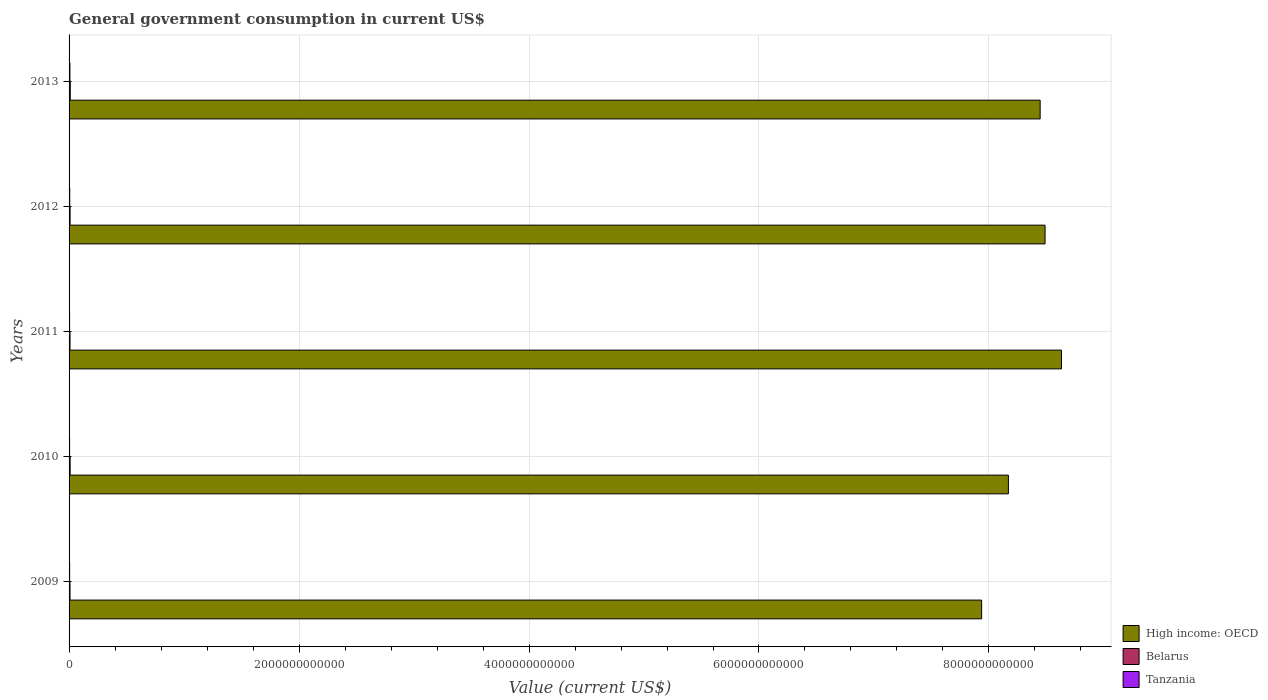How many different coloured bars are there?
Provide a short and direct response. 3. How many groups of bars are there?
Provide a succinct answer. 5. Are the number of bars on each tick of the Y-axis equal?
Your answer should be very brief. Yes. How many bars are there on the 2nd tick from the top?
Provide a succinct answer. 3. What is the label of the 3rd group of bars from the top?
Offer a very short reply. 2011. What is the government conusmption in Tanzania in 2012?
Provide a short and direct response. 5.76e+09. Across all years, what is the maximum government conusmption in Tanzania?
Make the answer very short. 7.24e+09. Across all years, what is the minimum government conusmption in High income: OECD?
Keep it short and to the point. 7.94e+12. In which year was the government conusmption in Belarus maximum?
Ensure brevity in your answer.  2013. In which year was the government conusmption in Belarus minimum?
Provide a short and direct response. 2009. What is the total government conusmption in High income: OECD in the graph?
Ensure brevity in your answer.  4.17e+13. What is the difference between the government conusmption in High income: OECD in 2010 and that in 2012?
Give a very brief answer. -3.19e+11. What is the difference between the government conusmption in High income: OECD in 2010 and the government conusmption in Belarus in 2011?
Your response must be concise. 8.16e+12. What is the average government conusmption in High income: OECD per year?
Ensure brevity in your answer.  8.33e+12. In the year 2009, what is the difference between the government conusmption in High income: OECD and government conusmption in Belarus?
Offer a terse response. 7.93e+12. What is the ratio of the government conusmption in Belarus in 2012 to that in 2013?
Give a very brief answer. 0.88. What is the difference between the highest and the second highest government conusmption in High income: OECD?
Provide a succinct answer. 1.42e+11. What is the difference between the highest and the lowest government conusmption in Tanzania?
Provide a succinct answer. 2.62e+09. In how many years, is the government conusmption in Belarus greater than the average government conusmption in Belarus taken over all years?
Give a very brief answer. 2. What does the 1st bar from the top in 2012 represents?
Your response must be concise. Tanzania. What does the 3rd bar from the bottom in 2009 represents?
Keep it short and to the point. Tanzania. How many bars are there?
Provide a short and direct response. 15. Are all the bars in the graph horizontal?
Offer a very short reply. Yes. How many years are there in the graph?
Give a very brief answer. 5. What is the difference between two consecutive major ticks on the X-axis?
Make the answer very short. 2.00e+12. Does the graph contain any zero values?
Give a very brief answer. No. Does the graph contain grids?
Your answer should be compact. Yes. Where does the legend appear in the graph?
Provide a short and direct response. Bottom right. How many legend labels are there?
Your answer should be very brief. 3. What is the title of the graph?
Make the answer very short. General government consumption in current US$. What is the label or title of the X-axis?
Your response must be concise. Value (current US$). What is the label or title of the Y-axis?
Keep it short and to the point. Years. What is the Value (current US$) in High income: OECD in 2009?
Ensure brevity in your answer.  7.94e+12. What is the Value (current US$) in Belarus in 2009?
Provide a succinct answer. 8.24e+09. What is the Value (current US$) of Tanzania in 2009?
Your answer should be very brief. 5.00e+09. What is the Value (current US$) in High income: OECD in 2010?
Provide a succinct answer. 8.17e+12. What is the Value (current US$) of Belarus in 2010?
Ensure brevity in your answer.  9.28e+09. What is the Value (current US$) of Tanzania in 2010?
Provide a succinct answer. 4.62e+09. What is the Value (current US$) of High income: OECD in 2011?
Provide a short and direct response. 8.63e+12. What is the Value (current US$) of Belarus in 2011?
Offer a very short reply. 8.32e+09. What is the Value (current US$) of Tanzania in 2011?
Your answer should be compact. 4.68e+09. What is the Value (current US$) in High income: OECD in 2012?
Ensure brevity in your answer.  8.49e+12. What is the Value (current US$) in Belarus in 2012?
Make the answer very short. 8.96e+09. What is the Value (current US$) in Tanzania in 2012?
Offer a terse response. 5.76e+09. What is the Value (current US$) of High income: OECD in 2013?
Ensure brevity in your answer.  8.45e+12. What is the Value (current US$) in Belarus in 2013?
Offer a very short reply. 1.02e+1. What is the Value (current US$) in Tanzania in 2013?
Your response must be concise. 7.24e+09. Across all years, what is the maximum Value (current US$) of High income: OECD?
Make the answer very short. 8.63e+12. Across all years, what is the maximum Value (current US$) in Belarus?
Make the answer very short. 1.02e+1. Across all years, what is the maximum Value (current US$) in Tanzania?
Provide a succinct answer. 7.24e+09. Across all years, what is the minimum Value (current US$) in High income: OECD?
Your answer should be very brief. 7.94e+12. Across all years, what is the minimum Value (current US$) in Belarus?
Provide a short and direct response. 8.24e+09. Across all years, what is the minimum Value (current US$) in Tanzania?
Offer a very short reply. 4.62e+09. What is the total Value (current US$) in High income: OECD in the graph?
Your answer should be very brief. 4.17e+13. What is the total Value (current US$) in Belarus in the graph?
Provide a short and direct response. 4.50e+1. What is the total Value (current US$) in Tanzania in the graph?
Keep it short and to the point. 2.73e+1. What is the difference between the Value (current US$) of High income: OECD in 2009 and that in 2010?
Provide a succinct answer. -2.33e+11. What is the difference between the Value (current US$) in Belarus in 2009 and that in 2010?
Give a very brief answer. -1.04e+09. What is the difference between the Value (current US$) of Tanzania in 2009 and that in 2010?
Keep it short and to the point. 3.75e+08. What is the difference between the Value (current US$) of High income: OECD in 2009 and that in 2011?
Your answer should be compact. -6.94e+11. What is the difference between the Value (current US$) of Belarus in 2009 and that in 2011?
Keep it short and to the point. -8.45e+07. What is the difference between the Value (current US$) in Tanzania in 2009 and that in 2011?
Offer a very short reply. 3.15e+08. What is the difference between the Value (current US$) of High income: OECD in 2009 and that in 2012?
Make the answer very short. -5.52e+11. What is the difference between the Value (current US$) in Belarus in 2009 and that in 2012?
Offer a terse response. -7.26e+08. What is the difference between the Value (current US$) of Tanzania in 2009 and that in 2012?
Make the answer very short. -7.63e+08. What is the difference between the Value (current US$) in High income: OECD in 2009 and that in 2013?
Provide a succinct answer. -5.09e+11. What is the difference between the Value (current US$) of Belarus in 2009 and that in 2013?
Provide a succinct answer. -2.00e+09. What is the difference between the Value (current US$) in Tanzania in 2009 and that in 2013?
Provide a short and direct response. -2.25e+09. What is the difference between the Value (current US$) of High income: OECD in 2010 and that in 2011?
Give a very brief answer. -4.62e+11. What is the difference between the Value (current US$) of Belarus in 2010 and that in 2011?
Make the answer very short. 9.60e+08. What is the difference between the Value (current US$) of Tanzania in 2010 and that in 2011?
Offer a very short reply. -6.07e+07. What is the difference between the Value (current US$) of High income: OECD in 2010 and that in 2012?
Keep it short and to the point. -3.19e+11. What is the difference between the Value (current US$) in Belarus in 2010 and that in 2012?
Ensure brevity in your answer.  3.18e+08. What is the difference between the Value (current US$) of Tanzania in 2010 and that in 2012?
Provide a succinct answer. -1.14e+09. What is the difference between the Value (current US$) of High income: OECD in 2010 and that in 2013?
Your answer should be very brief. -2.76e+11. What is the difference between the Value (current US$) in Belarus in 2010 and that in 2013?
Your answer should be compact. -9.56e+08. What is the difference between the Value (current US$) of Tanzania in 2010 and that in 2013?
Keep it short and to the point. -2.62e+09. What is the difference between the Value (current US$) in High income: OECD in 2011 and that in 2012?
Ensure brevity in your answer.  1.42e+11. What is the difference between the Value (current US$) of Belarus in 2011 and that in 2012?
Keep it short and to the point. -6.41e+08. What is the difference between the Value (current US$) in Tanzania in 2011 and that in 2012?
Your answer should be very brief. -1.08e+09. What is the difference between the Value (current US$) of High income: OECD in 2011 and that in 2013?
Keep it short and to the point. 1.85e+11. What is the difference between the Value (current US$) in Belarus in 2011 and that in 2013?
Keep it short and to the point. -1.92e+09. What is the difference between the Value (current US$) of Tanzania in 2011 and that in 2013?
Ensure brevity in your answer.  -2.56e+09. What is the difference between the Value (current US$) of High income: OECD in 2012 and that in 2013?
Offer a terse response. 4.29e+1. What is the difference between the Value (current US$) of Belarus in 2012 and that in 2013?
Provide a succinct answer. -1.27e+09. What is the difference between the Value (current US$) of Tanzania in 2012 and that in 2013?
Ensure brevity in your answer.  -1.48e+09. What is the difference between the Value (current US$) in High income: OECD in 2009 and the Value (current US$) in Belarus in 2010?
Provide a short and direct response. 7.93e+12. What is the difference between the Value (current US$) in High income: OECD in 2009 and the Value (current US$) in Tanzania in 2010?
Offer a very short reply. 7.93e+12. What is the difference between the Value (current US$) in Belarus in 2009 and the Value (current US$) in Tanzania in 2010?
Make the answer very short. 3.61e+09. What is the difference between the Value (current US$) of High income: OECD in 2009 and the Value (current US$) of Belarus in 2011?
Keep it short and to the point. 7.93e+12. What is the difference between the Value (current US$) in High income: OECD in 2009 and the Value (current US$) in Tanzania in 2011?
Provide a short and direct response. 7.93e+12. What is the difference between the Value (current US$) of Belarus in 2009 and the Value (current US$) of Tanzania in 2011?
Your answer should be compact. 3.55e+09. What is the difference between the Value (current US$) in High income: OECD in 2009 and the Value (current US$) in Belarus in 2012?
Offer a very short reply. 7.93e+12. What is the difference between the Value (current US$) in High income: OECD in 2009 and the Value (current US$) in Tanzania in 2012?
Your answer should be compact. 7.93e+12. What is the difference between the Value (current US$) of Belarus in 2009 and the Value (current US$) of Tanzania in 2012?
Keep it short and to the point. 2.47e+09. What is the difference between the Value (current US$) in High income: OECD in 2009 and the Value (current US$) in Belarus in 2013?
Offer a terse response. 7.93e+12. What is the difference between the Value (current US$) in High income: OECD in 2009 and the Value (current US$) in Tanzania in 2013?
Your answer should be very brief. 7.93e+12. What is the difference between the Value (current US$) in Belarus in 2009 and the Value (current US$) in Tanzania in 2013?
Provide a short and direct response. 9.91e+08. What is the difference between the Value (current US$) of High income: OECD in 2010 and the Value (current US$) of Belarus in 2011?
Your answer should be very brief. 8.16e+12. What is the difference between the Value (current US$) of High income: OECD in 2010 and the Value (current US$) of Tanzania in 2011?
Ensure brevity in your answer.  8.16e+12. What is the difference between the Value (current US$) in Belarus in 2010 and the Value (current US$) in Tanzania in 2011?
Your answer should be compact. 4.60e+09. What is the difference between the Value (current US$) of High income: OECD in 2010 and the Value (current US$) of Belarus in 2012?
Your response must be concise. 8.16e+12. What is the difference between the Value (current US$) of High income: OECD in 2010 and the Value (current US$) of Tanzania in 2012?
Your answer should be compact. 8.16e+12. What is the difference between the Value (current US$) in Belarus in 2010 and the Value (current US$) in Tanzania in 2012?
Offer a very short reply. 3.52e+09. What is the difference between the Value (current US$) of High income: OECD in 2010 and the Value (current US$) of Belarus in 2013?
Provide a succinct answer. 8.16e+12. What is the difference between the Value (current US$) of High income: OECD in 2010 and the Value (current US$) of Tanzania in 2013?
Your response must be concise. 8.16e+12. What is the difference between the Value (current US$) in Belarus in 2010 and the Value (current US$) in Tanzania in 2013?
Your response must be concise. 2.04e+09. What is the difference between the Value (current US$) of High income: OECD in 2011 and the Value (current US$) of Belarus in 2012?
Ensure brevity in your answer.  8.62e+12. What is the difference between the Value (current US$) of High income: OECD in 2011 and the Value (current US$) of Tanzania in 2012?
Provide a succinct answer. 8.62e+12. What is the difference between the Value (current US$) of Belarus in 2011 and the Value (current US$) of Tanzania in 2012?
Your answer should be very brief. 2.56e+09. What is the difference between the Value (current US$) in High income: OECD in 2011 and the Value (current US$) in Belarus in 2013?
Make the answer very short. 8.62e+12. What is the difference between the Value (current US$) of High income: OECD in 2011 and the Value (current US$) of Tanzania in 2013?
Your answer should be compact. 8.62e+12. What is the difference between the Value (current US$) of Belarus in 2011 and the Value (current US$) of Tanzania in 2013?
Ensure brevity in your answer.  1.08e+09. What is the difference between the Value (current US$) of High income: OECD in 2012 and the Value (current US$) of Belarus in 2013?
Keep it short and to the point. 8.48e+12. What is the difference between the Value (current US$) of High income: OECD in 2012 and the Value (current US$) of Tanzania in 2013?
Your answer should be compact. 8.48e+12. What is the difference between the Value (current US$) of Belarus in 2012 and the Value (current US$) of Tanzania in 2013?
Offer a very short reply. 1.72e+09. What is the average Value (current US$) in High income: OECD per year?
Keep it short and to the point. 8.33e+12. What is the average Value (current US$) of Belarus per year?
Your answer should be compact. 9.01e+09. What is the average Value (current US$) of Tanzania per year?
Keep it short and to the point. 5.46e+09. In the year 2009, what is the difference between the Value (current US$) in High income: OECD and Value (current US$) in Belarus?
Your answer should be very brief. 7.93e+12. In the year 2009, what is the difference between the Value (current US$) in High income: OECD and Value (current US$) in Tanzania?
Offer a very short reply. 7.93e+12. In the year 2009, what is the difference between the Value (current US$) in Belarus and Value (current US$) in Tanzania?
Your answer should be very brief. 3.24e+09. In the year 2010, what is the difference between the Value (current US$) of High income: OECD and Value (current US$) of Belarus?
Give a very brief answer. 8.16e+12. In the year 2010, what is the difference between the Value (current US$) in High income: OECD and Value (current US$) in Tanzania?
Make the answer very short. 8.16e+12. In the year 2010, what is the difference between the Value (current US$) in Belarus and Value (current US$) in Tanzania?
Make the answer very short. 4.66e+09. In the year 2011, what is the difference between the Value (current US$) in High income: OECD and Value (current US$) in Belarus?
Give a very brief answer. 8.62e+12. In the year 2011, what is the difference between the Value (current US$) in High income: OECD and Value (current US$) in Tanzania?
Your answer should be compact. 8.63e+12. In the year 2011, what is the difference between the Value (current US$) of Belarus and Value (current US$) of Tanzania?
Your answer should be compact. 3.64e+09. In the year 2012, what is the difference between the Value (current US$) in High income: OECD and Value (current US$) in Belarus?
Provide a succinct answer. 8.48e+12. In the year 2012, what is the difference between the Value (current US$) in High income: OECD and Value (current US$) in Tanzania?
Provide a succinct answer. 8.48e+12. In the year 2012, what is the difference between the Value (current US$) in Belarus and Value (current US$) in Tanzania?
Provide a succinct answer. 3.20e+09. In the year 2013, what is the difference between the Value (current US$) of High income: OECD and Value (current US$) of Belarus?
Offer a terse response. 8.43e+12. In the year 2013, what is the difference between the Value (current US$) of High income: OECD and Value (current US$) of Tanzania?
Provide a short and direct response. 8.44e+12. In the year 2013, what is the difference between the Value (current US$) in Belarus and Value (current US$) in Tanzania?
Provide a short and direct response. 2.99e+09. What is the ratio of the Value (current US$) of High income: OECD in 2009 to that in 2010?
Provide a succinct answer. 0.97. What is the ratio of the Value (current US$) of Belarus in 2009 to that in 2010?
Give a very brief answer. 0.89. What is the ratio of the Value (current US$) in Tanzania in 2009 to that in 2010?
Provide a succinct answer. 1.08. What is the ratio of the Value (current US$) in High income: OECD in 2009 to that in 2011?
Provide a succinct answer. 0.92. What is the ratio of the Value (current US$) of Belarus in 2009 to that in 2011?
Your answer should be very brief. 0.99. What is the ratio of the Value (current US$) of Tanzania in 2009 to that in 2011?
Your answer should be very brief. 1.07. What is the ratio of the Value (current US$) in High income: OECD in 2009 to that in 2012?
Keep it short and to the point. 0.94. What is the ratio of the Value (current US$) in Belarus in 2009 to that in 2012?
Offer a very short reply. 0.92. What is the ratio of the Value (current US$) in Tanzania in 2009 to that in 2012?
Your response must be concise. 0.87. What is the ratio of the Value (current US$) in High income: OECD in 2009 to that in 2013?
Offer a very short reply. 0.94. What is the ratio of the Value (current US$) in Belarus in 2009 to that in 2013?
Your answer should be compact. 0.8. What is the ratio of the Value (current US$) of Tanzania in 2009 to that in 2013?
Offer a very short reply. 0.69. What is the ratio of the Value (current US$) in High income: OECD in 2010 to that in 2011?
Your answer should be compact. 0.95. What is the ratio of the Value (current US$) of Belarus in 2010 to that in 2011?
Keep it short and to the point. 1.12. What is the ratio of the Value (current US$) of Tanzania in 2010 to that in 2011?
Offer a terse response. 0.99. What is the ratio of the Value (current US$) of High income: OECD in 2010 to that in 2012?
Your answer should be compact. 0.96. What is the ratio of the Value (current US$) of Belarus in 2010 to that in 2012?
Provide a short and direct response. 1.04. What is the ratio of the Value (current US$) of Tanzania in 2010 to that in 2012?
Ensure brevity in your answer.  0.8. What is the ratio of the Value (current US$) in High income: OECD in 2010 to that in 2013?
Give a very brief answer. 0.97. What is the ratio of the Value (current US$) in Belarus in 2010 to that in 2013?
Offer a terse response. 0.91. What is the ratio of the Value (current US$) in Tanzania in 2010 to that in 2013?
Provide a short and direct response. 0.64. What is the ratio of the Value (current US$) of High income: OECD in 2011 to that in 2012?
Provide a short and direct response. 1.02. What is the ratio of the Value (current US$) of Belarus in 2011 to that in 2012?
Provide a short and direct response. 0.93. What is the ratio of the Value (current US$) in Tanzania in 2011 to that in 2012?
Offer a very short reply. 0.81. What is the ratio of the Value (current US$) of High income: OECD in 2011 to that in 2013?
Offer a terse response. 1.02. What is the ratio of the Value (current US$) in Belarus in 2011 to that in 2013?
Provide a succinct answer. 0.81. What is the ratio of the Value (current US$) in Tanzania in 2011 to that in 2013?
Give a very brief answer. 0.65. What is the ratio of the Value (current US$) in Belarus in 2012 to that in 2013?
Your answer should be very brief. 0.88. What is the ratio of the Value (current US$) in Tanzania in 2012 to that in 2013?
Provide a short and direct response. 0.8. What is the difference between the highest and the second highest Value (current US$) of High income: OECD?
Your answer should be compact. 1.42e+11. What is the difference between the highest and the second highest Value (current US$) in Belarus?
Give a very brief answer. 9.56e+08. What is the difference between the highest and the second highest Value (current US$) in Tanzania?
Your answer should be very brief. 1.48e+09. What is the difference between the highest and the lowest Value (current US$) of High income: OECD?
Provide a short and direct response. 6.94e+11. What is the difference between the highest and the lowest Value (current US$) in Belarus?
Your response must be concise. 2.00e+09. What is the difference between the highest and the lowest Value (current US$) in Tanzania?
Ensure brevity in your answer.  2.62e+09. 